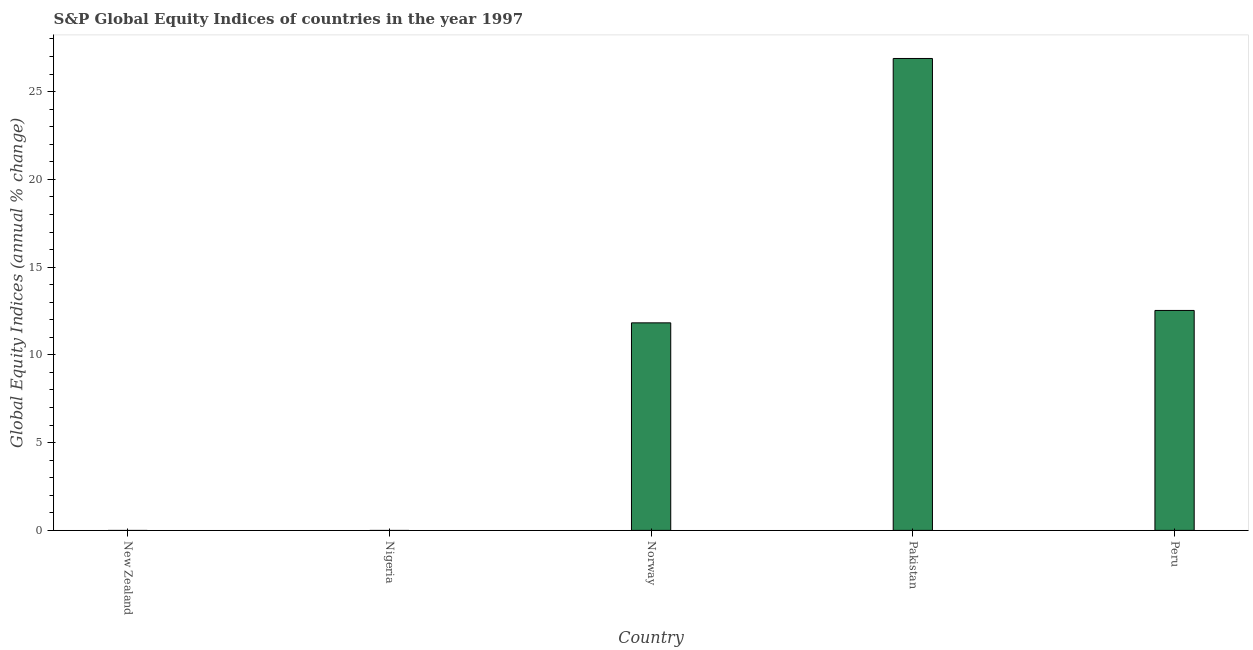What is the title of the graph?
Offer a very short reply. S&P Global Equity Indices of countries in the year 1997. What is the label or title of the X-axis?
Provide a succinct answer. Country. What is the label or title of the Y-axis?
Keep it short and to the point. Global Equity Indices (annual % change). What is the s&p global equity indices in Nigeria?
Your answer should be compact. 0. Across all countries, what is the maximum s&p global equity indices?
Keep it short and to the point. 26.89. Across all countries, what is the minimum s&p global equity indices?
Offer a very short reply. 0. What is the sum of the s&p global equity indices?
Provide a succinct answer. 51.25. What is the average s&p global equity indices per country?
Your response must be concise. 10.25. What is the median s&p global equity indices?
Your response must be concise. 11.83. In how many countries, is the s&p global equity indices greater than 2 %?
Offer a terse response. 3. What is the ratio of the s&p global equity indices in Pakistan to that in Peru?
Ensure brevity in your answer.  2.15. What is the difference between the highest and the second highest s&p global equity indices?
Keep it short and to the point. 14.36. Is the sum of the s&p global equity indices in Pakistan and Peru greater than the maximum s&p global equity indices across all countries?
Provide a succinct answer. Yes. What is the difference between the highest and the lowest s&p global equity indices?
Your response must be concise. 26.89. Are all the bars in the graph horizontal?
Ensure brevity in your answer.  No. Are the values on the major ticks of Y-axis written in scientific E-notation?
Keep it short and to the point. No. What is the Global Equity Indices (annual % change) of New Zealand?
Offer a terse response. 0. What is the Global Equity Indices (annual % change) of Norway?
Keep it short and to the point. 11.83. What is the Global Equity Indices (annual % change) in Pakistan?
Provide a short and direct response. 26.89. What is the Global Equity Indices (annual % change) in Peru?
Give a very brief answer. 12.53. What is the difference between the Global Equity Indices (annual % change) in Norway and Pakistan?
Ensure brevity in your answer.  -15.06. What is the difference between the Global Equity Indices (annual % change) in Norway and Peru?
Ensure brevity in your answer.  -0.71. What is the difference between the Global Equity Indices (annual % change) in Pakistan and Peru?
Ensure brevity in your answer.  14.36. What is the ratio of the Global Equity Indices (annual % change) in Norway to that in Pakistan?
Your answer should be compact. 0.44. What is the ratio of the Global Equity Indices (annual % change) in Norway to that in Peru?
Give a very brief answer. 0.94. What is the ratio of the Global Equity Indices (annual % change) in Pakistan to that in Peru?
Offer a very short reply. 2.15. 